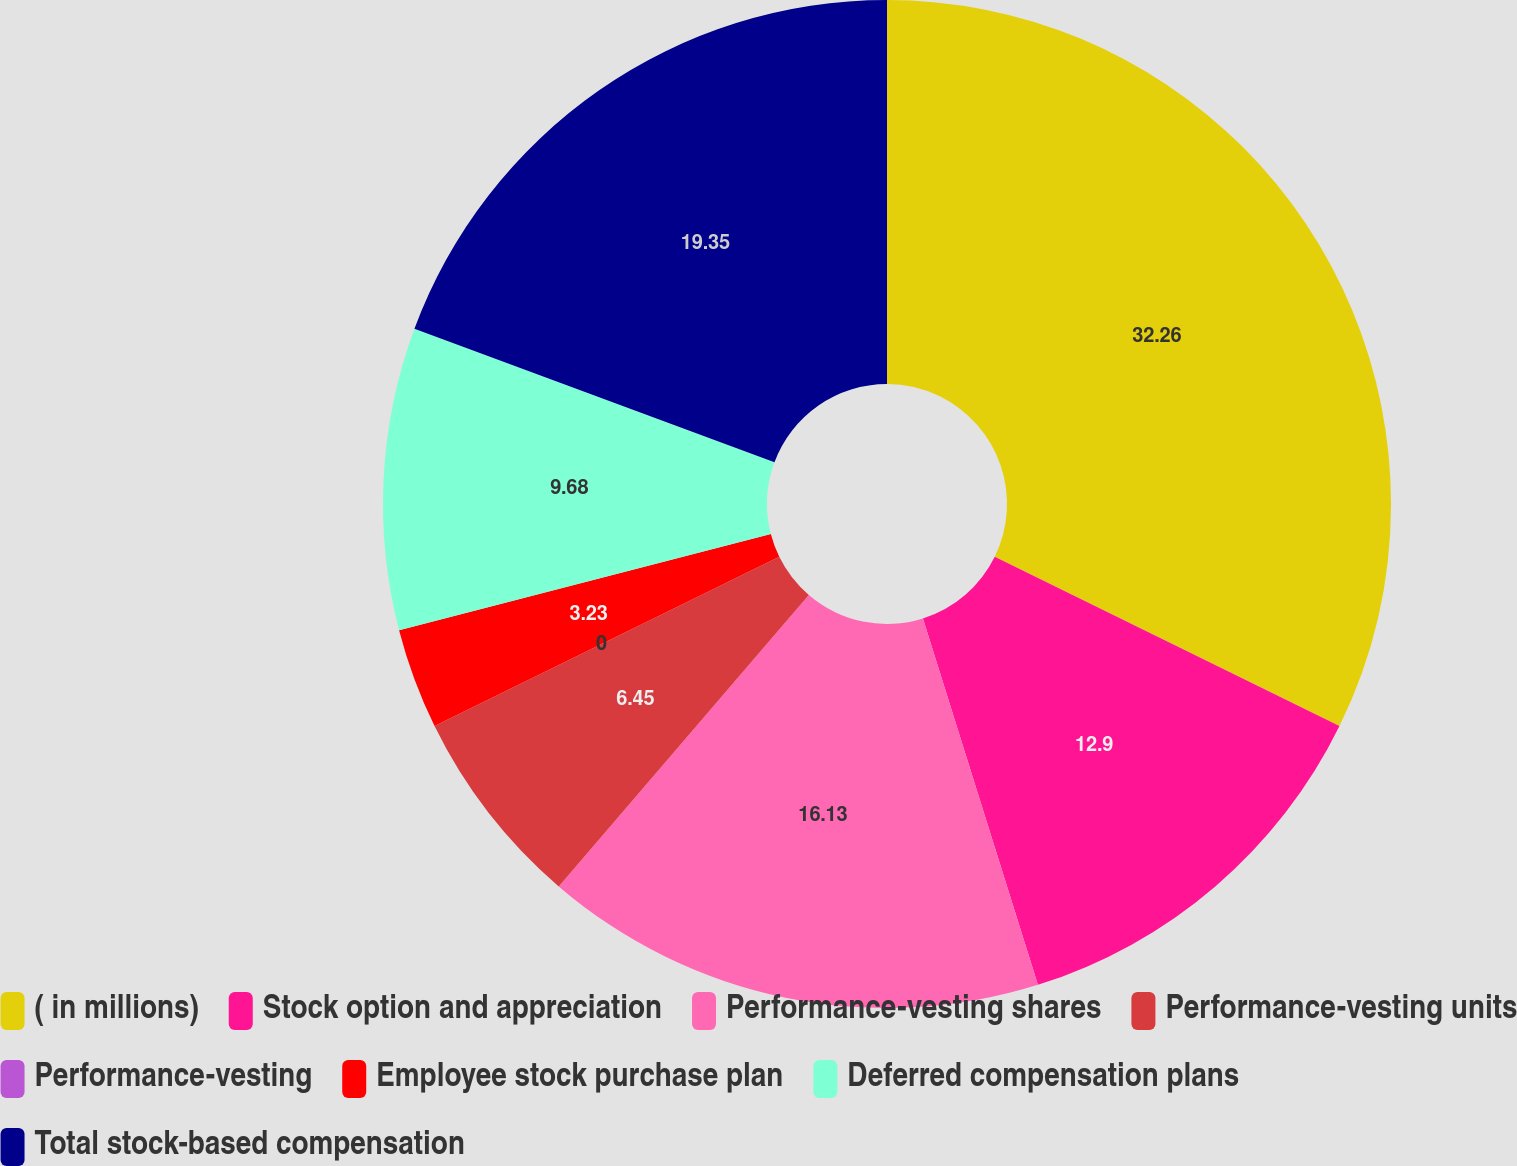Convert chart to OTSL. <chart><loc_0><loc_0><loc_500><loc_500><pie_chart><fcel>( in millions)<fcel>Stock option and appreciation<fcel>Performance-vesting shares<fcel>Performance-vesting units<fcel>Performance-vesting<fcel>Employee stock purchase plan<fcel>Deferred compensation plans<fcel>Total stock-based compensation<nl><fcel>32.26%<fcel>12.9%<fcel>16.13%<fcel>6.45%<fcel>0.0%<fcel>3.23%<fcel>9.68%<fcel>19.35%<nl></chart> 